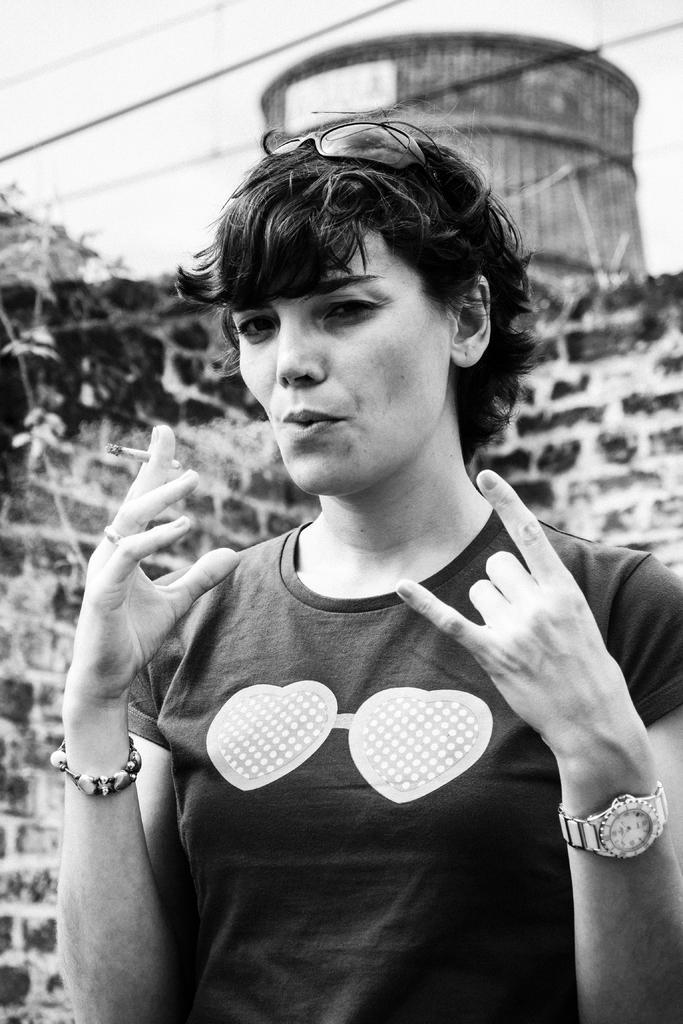Describe this image in one or two sentences. In the image there is a lady holding a cigarette in the hand. On her head there are goggles and also there is a watch on her hand. Behind her there is a wall, wires and also there is an object. 